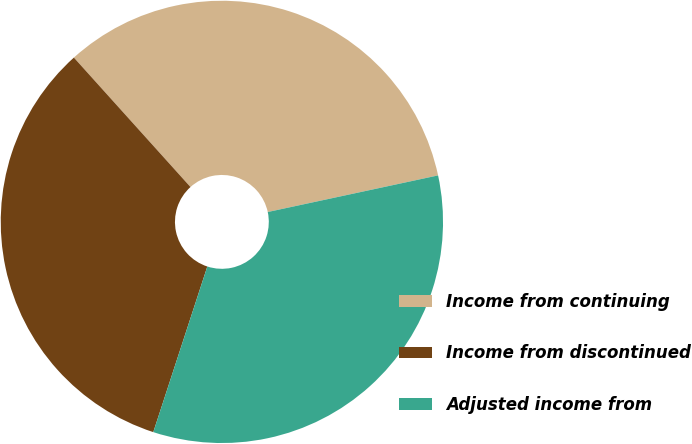Convert chart. <chart><loc_0><loc_0><loc_500><loc_500><pie_chart><fcel>Income from continuing<fcel>Income from discontinued<fcel>Adjusted income from<nl><fcel>33.3%<fcel>33.31%<fcel>33.39%<nl></chart> 